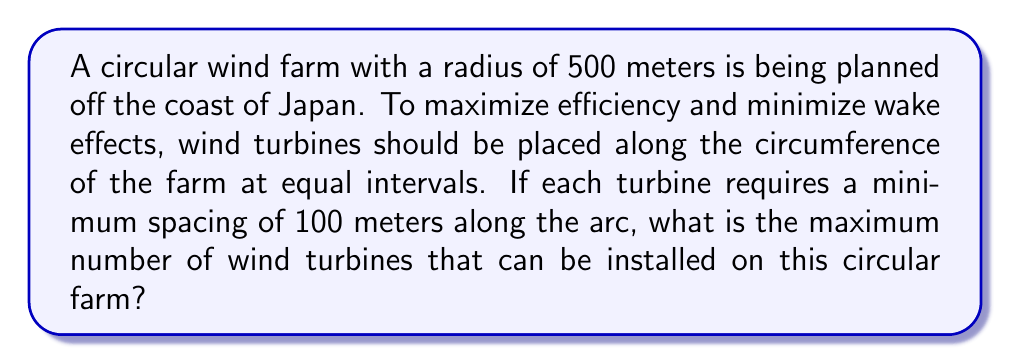Help me with this question. To solve this problem, we need to follow these steps:

1) First, calculate the circumference of the circular wind farm:
   $$ C = 2\pi r $$
   where $C$ is the circumference and $r$ is the radius.
   
   $$ C = 2\pi (500) = 1000\pi \approx 3141.59 \text{ meters} $$

2) Now, we need to determine how many 100-meter segments can fit along this circumference. We can do this by dividing the circumference by 100:

   $$ \text{Number of turbines} = \frac{C}{100} = \frac{1000\pi}{100} = 10\pi \approx 31.4159 $$

3) Since we can't install a fractional turbine, we need to round down to the nearest whole number.

[asy]
size(200);
draw(circle((0,0),5));
for(int i=0; i<31; ++i) {
  dot(5*dir(i*360/31));
}
label("500m",(-2.5,-2.5));
[/asy]

This diagram illustrates the circular wind farm with 31 equally spaced points along its circumference, representing the maximum number of turbines that can be installed.
Answer: The maximum number of wind turbines that can be installed is 31. 